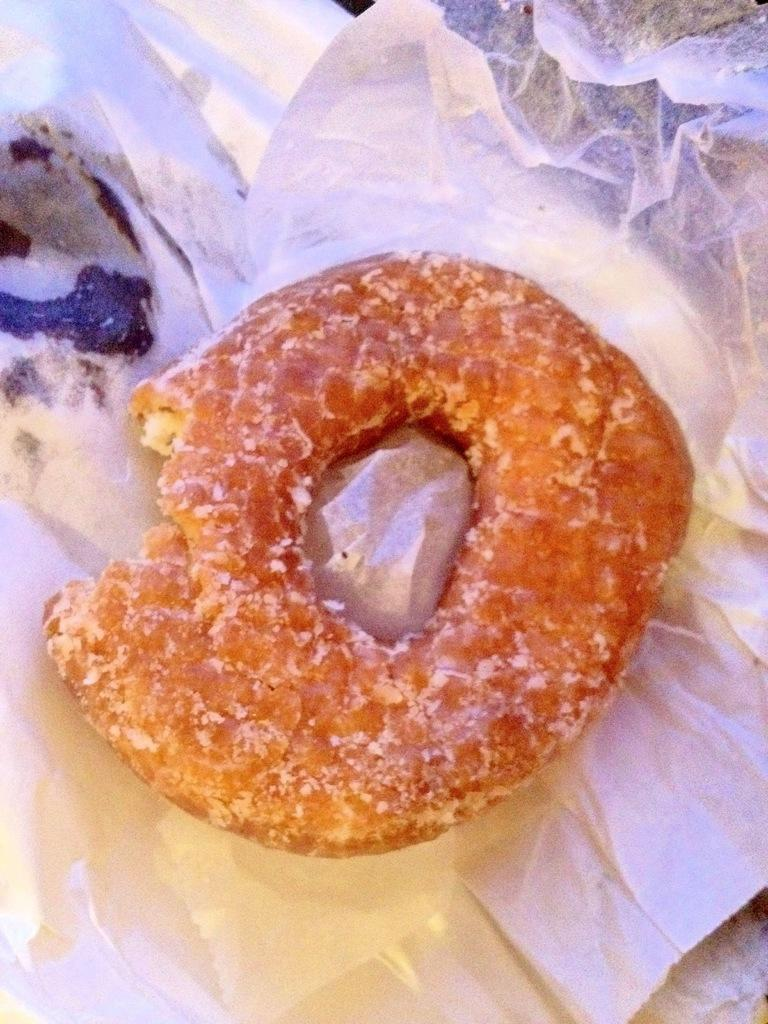What is the main subject of the image? The main subject of the image is a doughnut. Where is the doughnut placed? The doughnut is on a paper. What type of hole can be seen in the doughnut in the image? There is no hole visible in the doughnut in the image. What is being served for dinner in the image? The image does not depict a dinner scene, so it cannot be determined what is being served for dinner. 